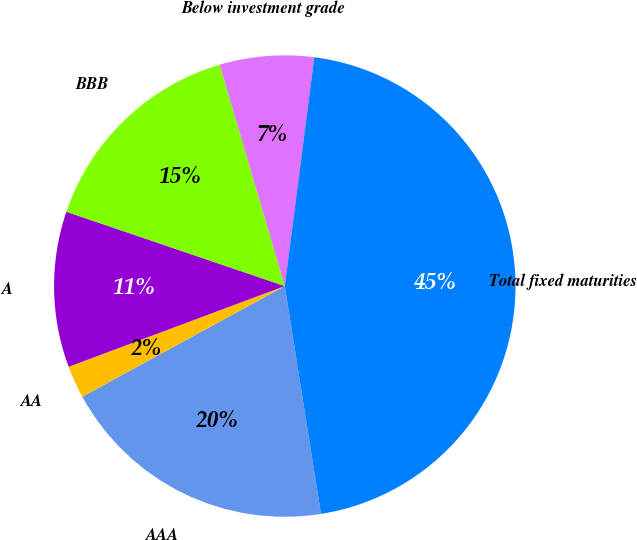<chart> <loc_0><loc_0><loc_500><loc_500><pie_chart><fcel>AAA<fcel>AA<fcel>A<fcel>BBB<fcel>Below investment grade<fcel>Total fixed maturities<nl><fcel>19.55%<fcel>2.27%<fcel>10.91%<fcel>15.23%<fcel>6.59%<fcel>45.45%<nl></chart> 